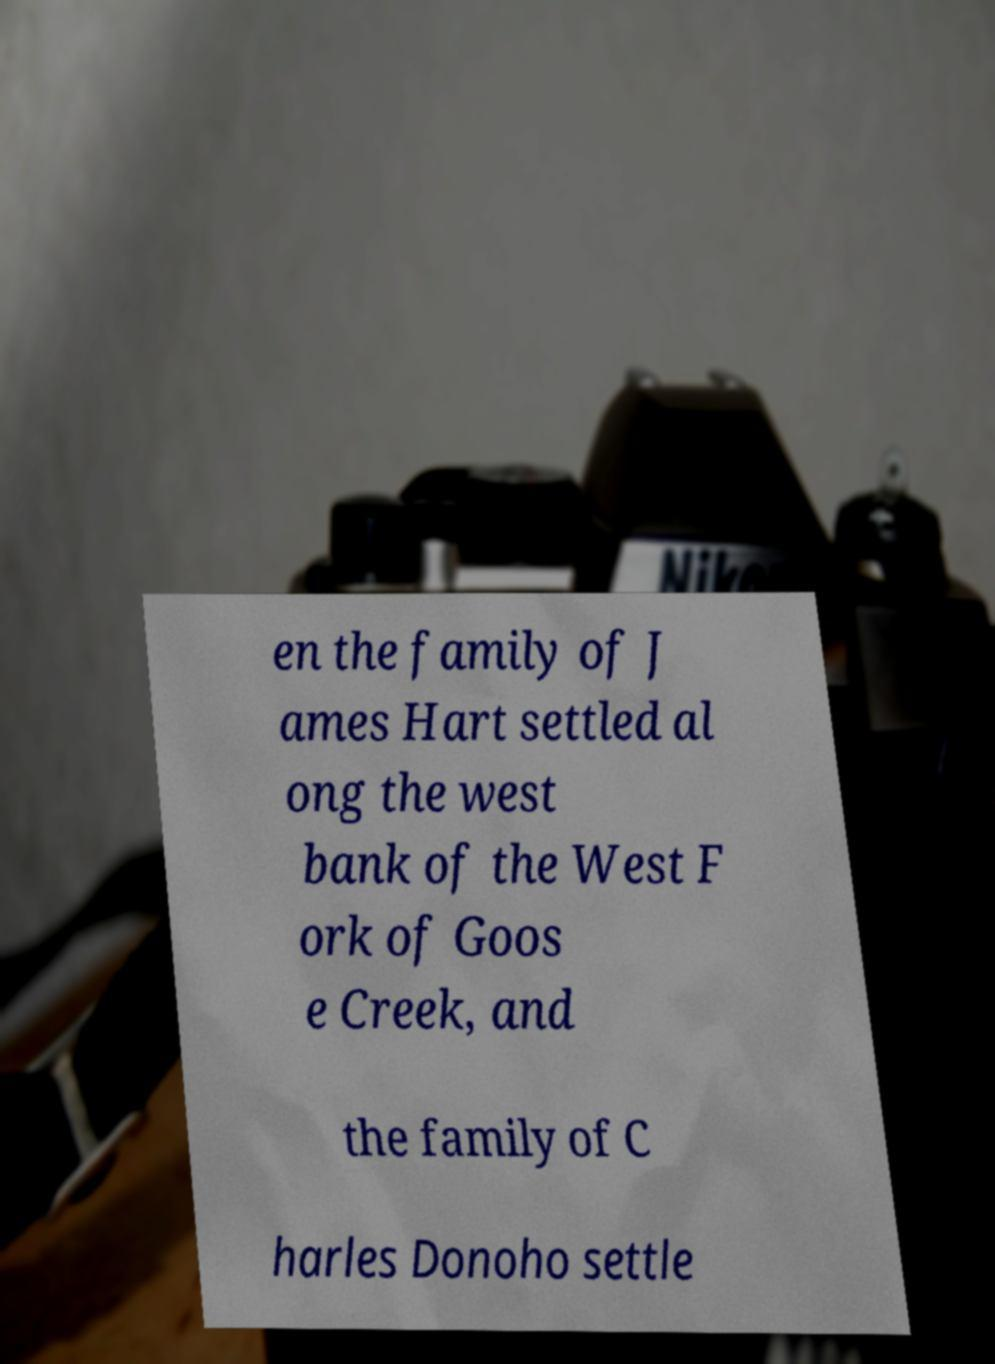Can you read and provide the text displayed in the image?This photo seems to have some interesting text. Can you extract and type it out for me? en the family of J ames Hart settled al ong the west bank of the West F ork of Goos e Creek, and the family of C harles Donoho settle 